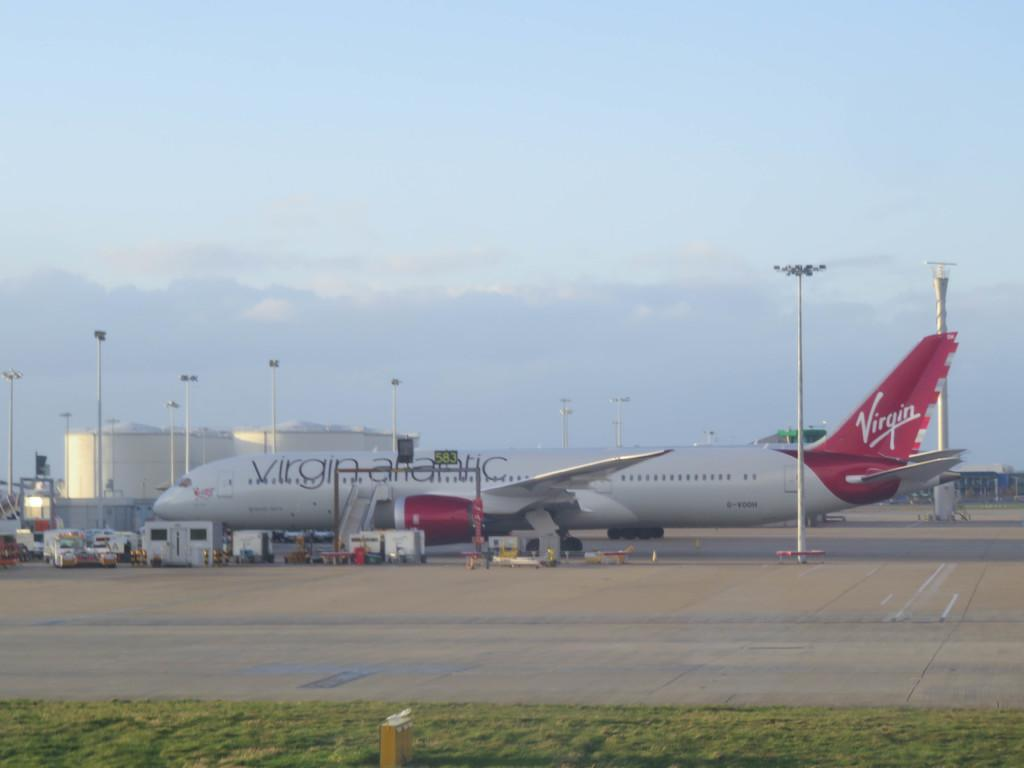<image>
Present a compact description of the photo's key features. An airplane from the company Virgin Airlines on the ground 